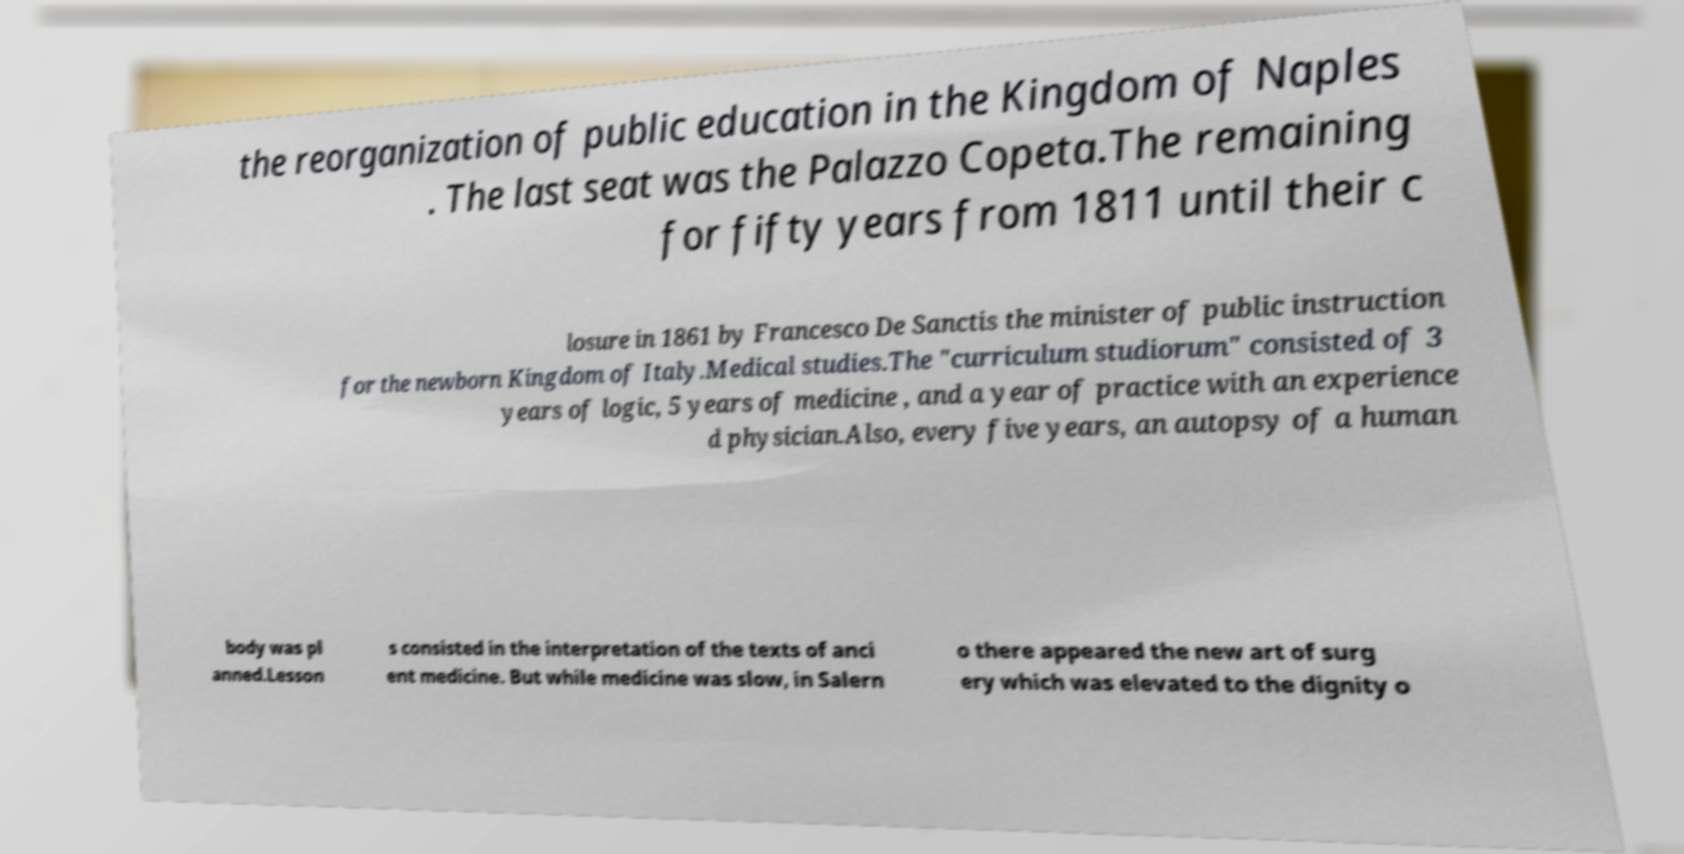I need the written content from this picture converted into text. Can you do that? the reorganization of public education in the Kingdom of Naples . The last seat was the Palazzo Copeta.The remaining for fifty years from 1811 until their c losure in 1861 by Francesco De Sanctis the minister of public instruction for the newborn Kingdom of Italy.Medical studies.The "curriculum studiorum" consisted of 3 years of logic, 5 years of medicine , and a year of practice with an experience d physician.Also, every five years, an autopsy of a human body was pl anned.Lesson s consisted in the interpretation of the texts of anci ent medicine. But while medicine was slow, in Salern o there appeared the new art of surg ery which was elevated to the dignity o 